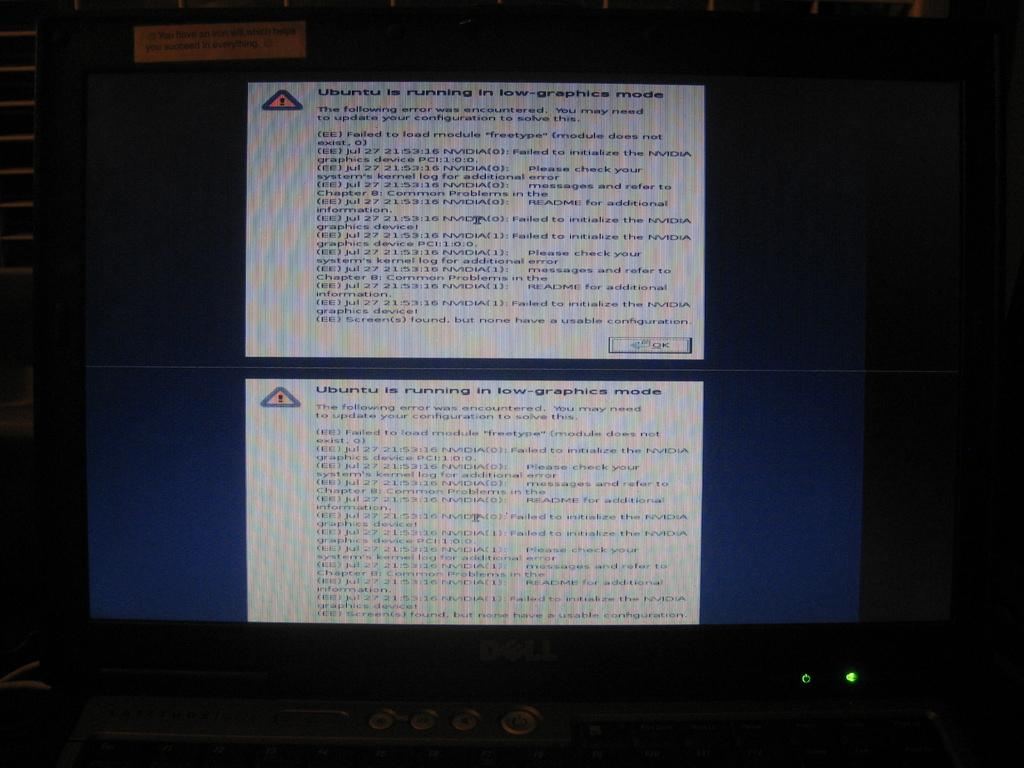<image>
Share a concise interpretation of the image provided. Message on a computer screen that starts with "Ubuntu". 